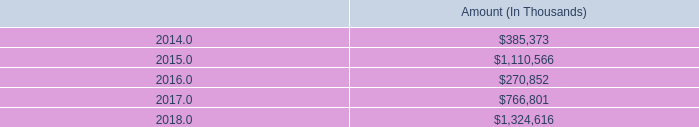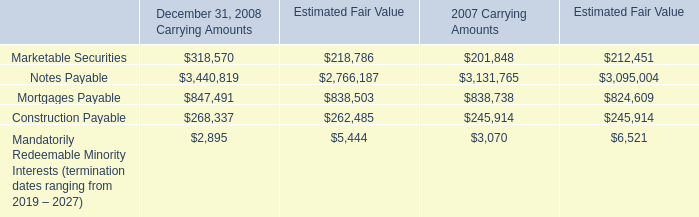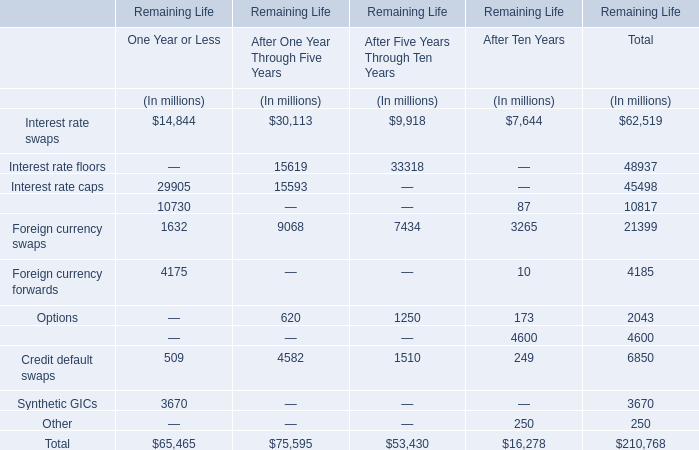What is the percentage of Interest rate swaps in relation to the total for After One Year Through Five Years ? 
Computations: (30113 / 75595)
Answer: 0.39835. 